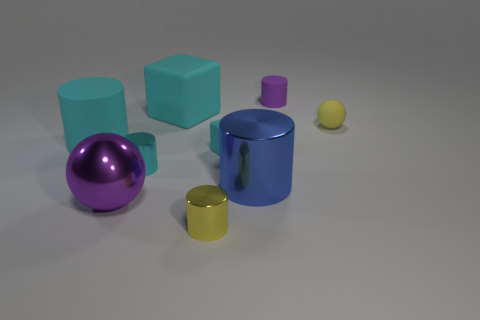Subtract all gray cylinders. Subtract all blue spheres. How many cylinders are left? 5 Add 1 tiny objects. How many objects exist? 10 Subtract all cubes. How many objects are left? 7 Subtract 0 blue cubes. How many objects are left? 9 Subtract all red metal things. Subtract all large purple spheres. How many objects are left? 8 Add 7 cyan shiny things. How many cyan shiny things are left? 8 Add 2 small cyan matte balls. How many small cyan matte balls exist? 2 